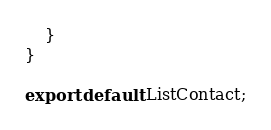<code> <loc_0><loc_0><loc_500><loc_500><_JavaScript_>    }
}

export default ListContact;
</code> 